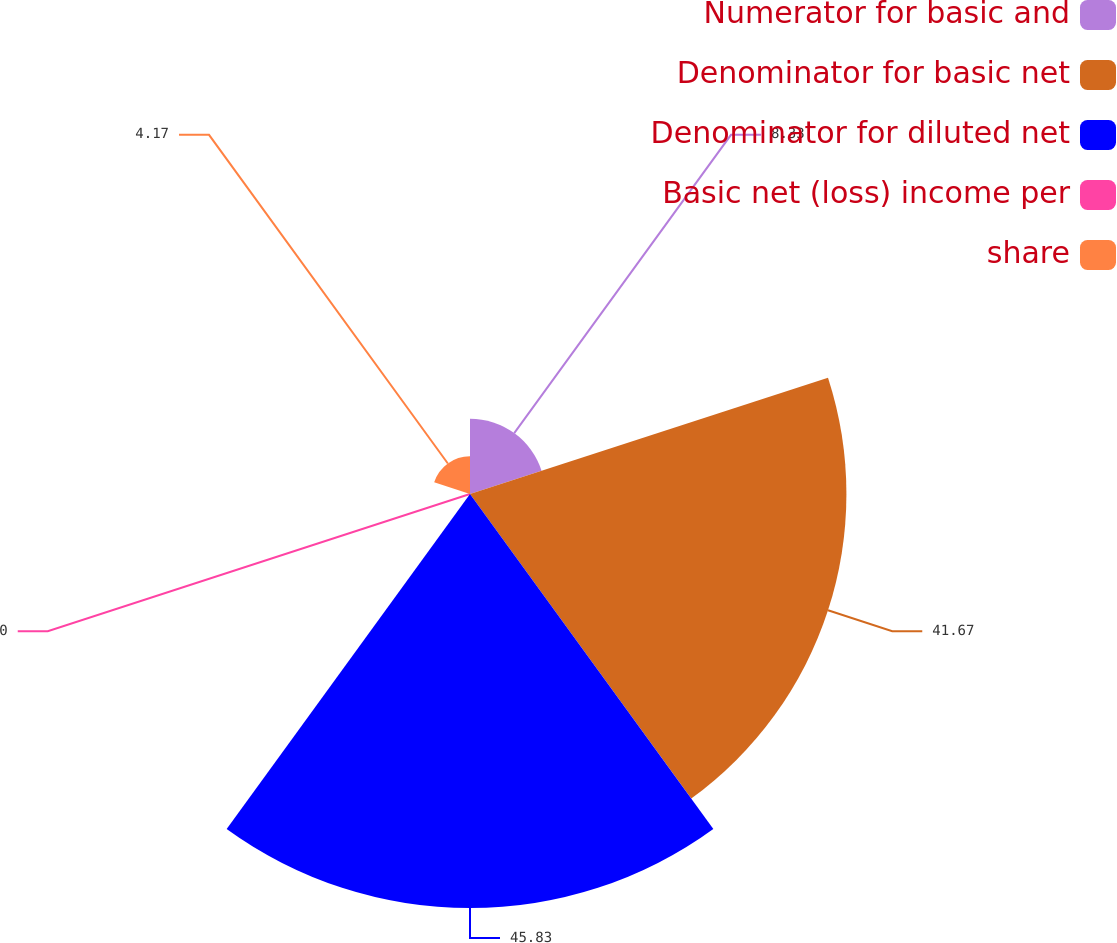Convert chart to OTSL. <chart><loc_0><loc_0><loc_500><loc_500><pie_chart><fcel>Numerator for basic and<fcel>Denominator for basic net<fcel>Denominator for diluted net<fcel>Basic net (loss) income per<fcel>share<nl><fcel>8.33%<fcel>41.67%<fcel>45.83%<fcel>0.0%<fcel>4.17%<nl></chart> 